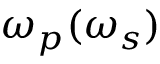Convert formula to latex. <formula><loc_0><loc_0><loc_500><loc_500>\omega _ { p } ( \omega _ { s } )</formula> 